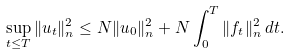Convert formula to latex. <formula><loc_0><loc_0><loc_500><loc_500>\sup _ { t \leq T } \| u _ { t } \| ^ { 2 } _ { n } \leq N \| u _ { 0 } \| ^ { 2 } _ { n } + N \int _ { 0 } ^ { T } \| f _ { t } \| ^ { 2 } _ { n } \, d t .</formula> 